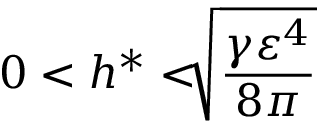<formula> <loc_0><loc_0><loc_500><loc_500>0 < h ^ { \ast } < \sqrt { [ } ] { \frac { \gamma \varepsilon ^ { 4 } } { 8 \pi } }</formula> 